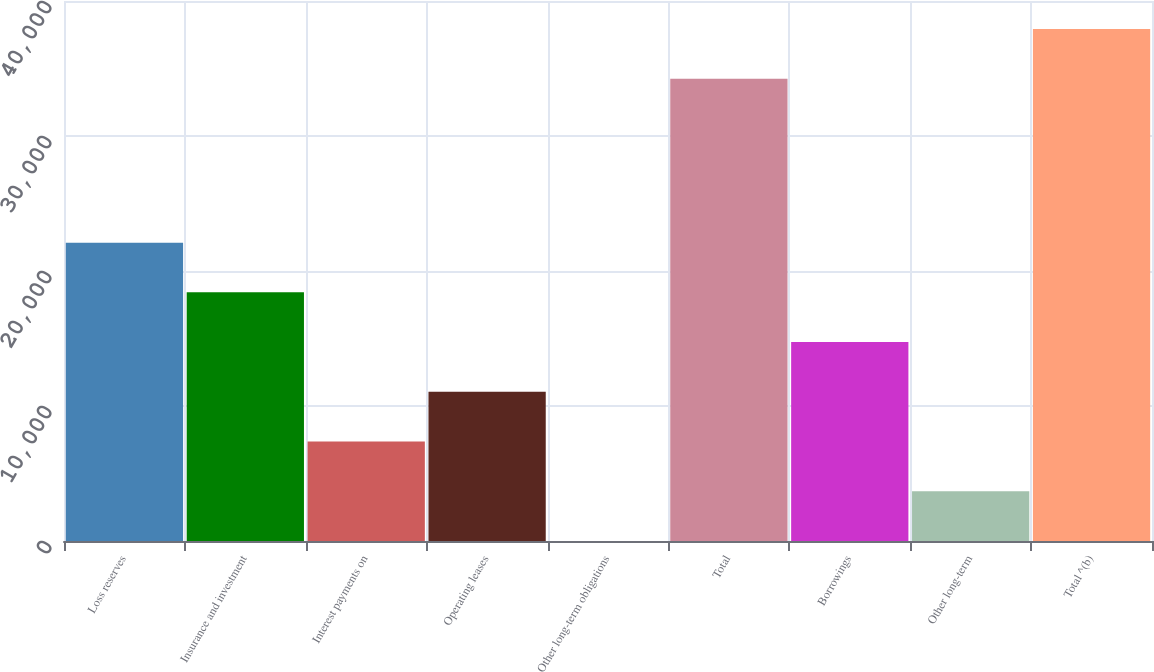Convert chart to OTSL. <chart><loc_0><loc_0><loc_500><loc_500><bar_chart><fcel>Loss reserves<fcel>Insurance and investment<fcel>Interest payments on<fcel>Operating leases<fcel>Other long-term obligations<fcel>Total<fcel>Borrowings<fcel>Other long-term<fcel>Total ^(b)<nl><fcel>22101.6<fcel>18418.5<fcel>7369.2<fcel>11052.3<fcel>3<fcel>34239<fcel>14735.4<fcel>3686.1<fcel>37922.1<nl></chart> 